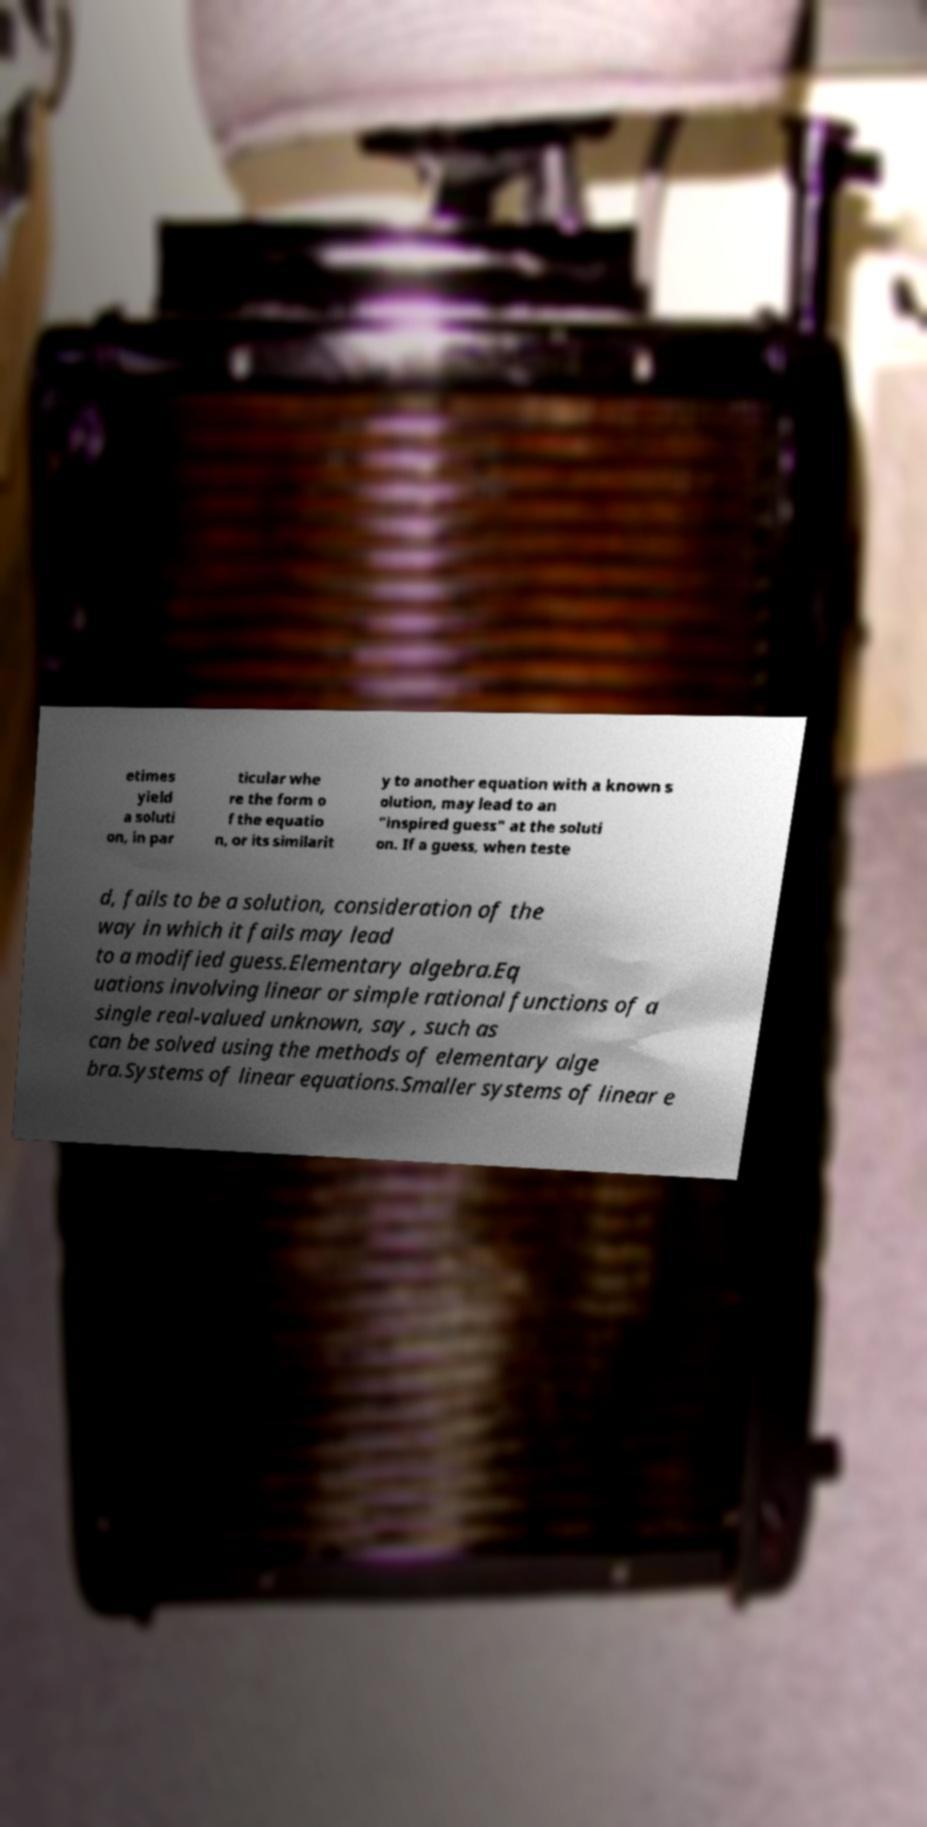Please identify and transcribe the text found in this image. etimes yield a soluti on, in par ticular whe re the form o f the equatio n, or its similarit y to another equation with a known s olution, may lead to an "inspired guess" at the soluti on. If a guess, when teste d, fails to be a solution, consideration of the way in which it fails may lead to a modified guess.Elementary algebra.Eq uations involving linear or simple rational functions of a single real-valued unknown, say , such as can be solved using the methods of elementary alge bra.Systems of linear equations.Smaller systems of linear e 